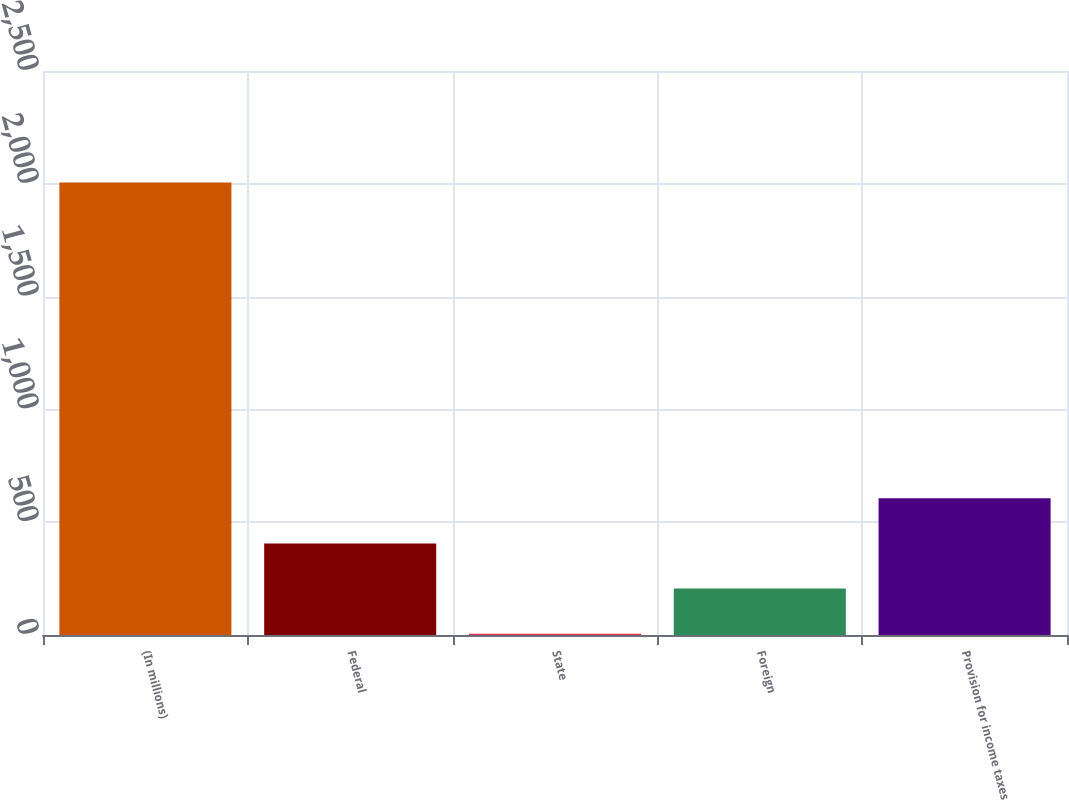Convert chart. <chart><loc_0><loc_0><loc_500><loc_500><bar_chart><fcel>(In millions)<fcel>Federal<fcel>State<fcel>Foreign<fcel>Provision for income taxes<nl><fcel>2006<fcel>406<fcel>6<fcel>206<fcel>606<nl></chart> 